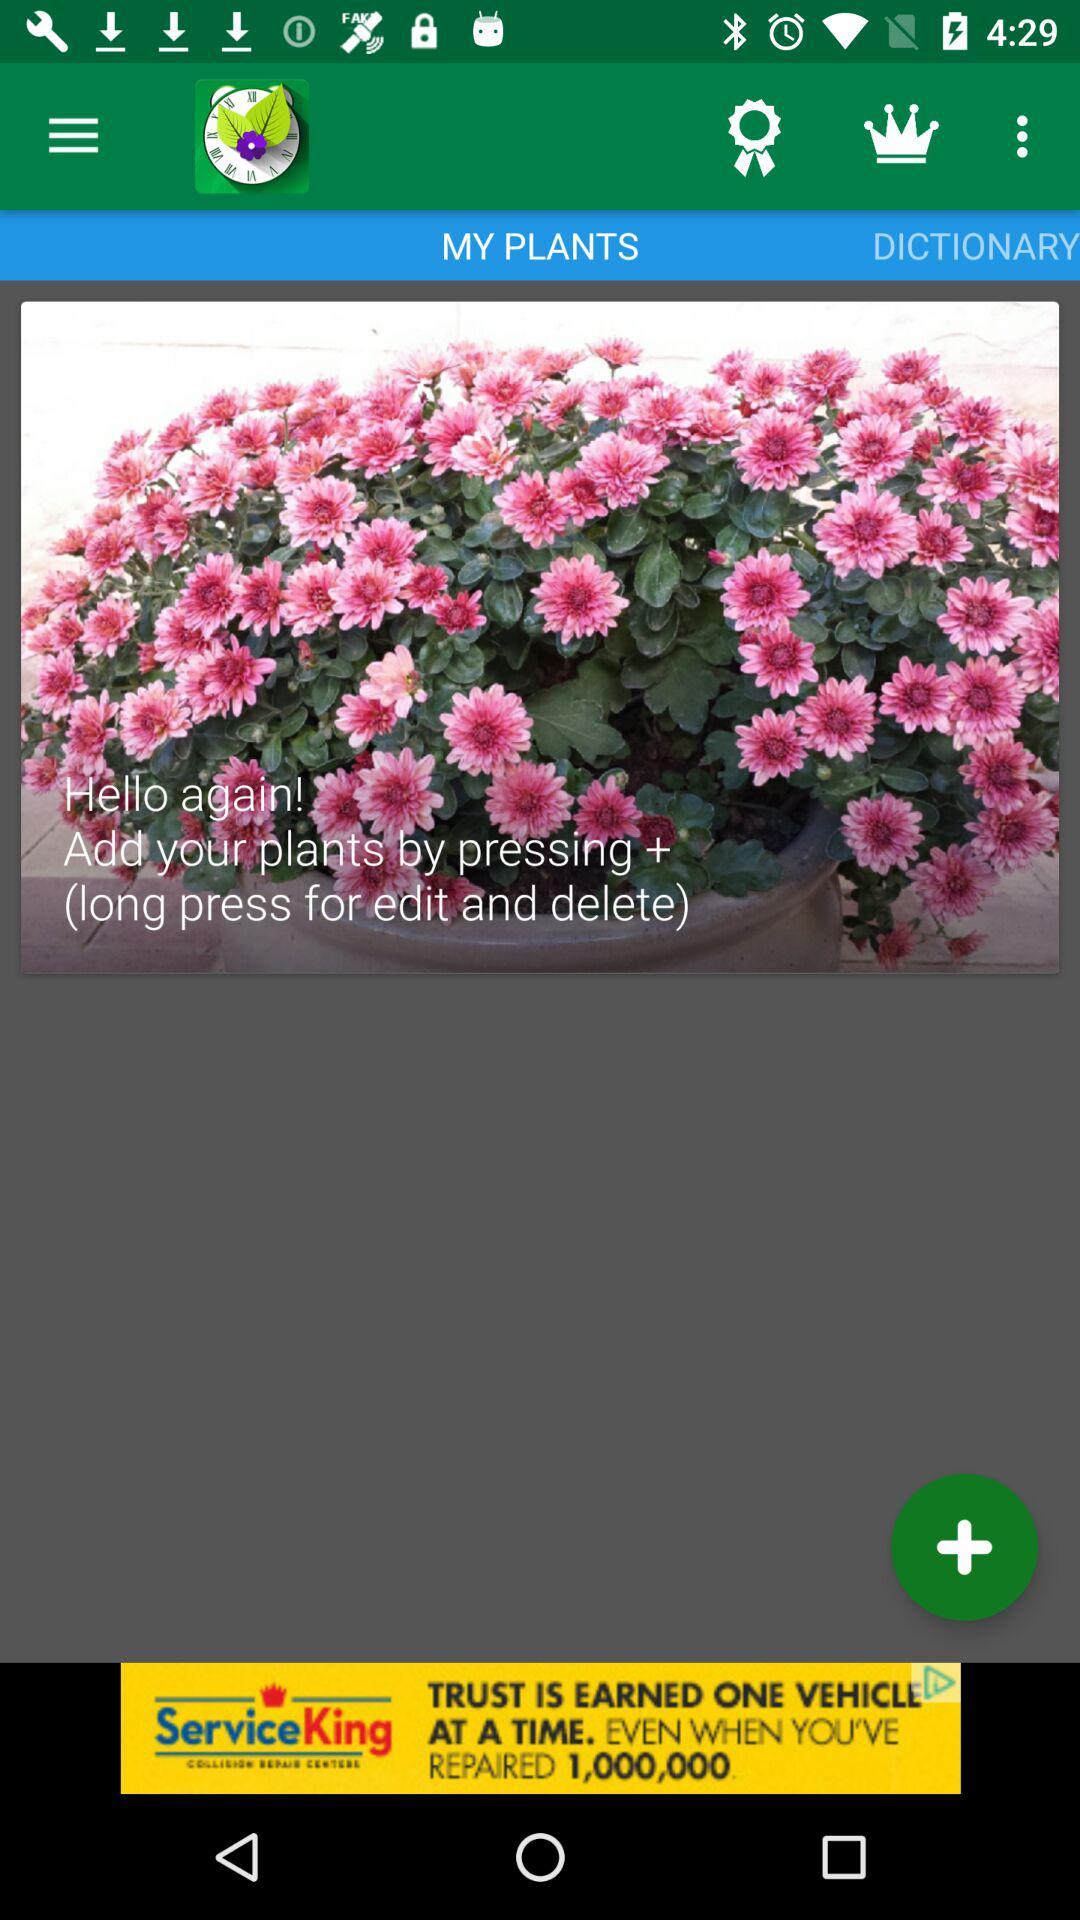How to add more plants? To add more plants, press "+". 